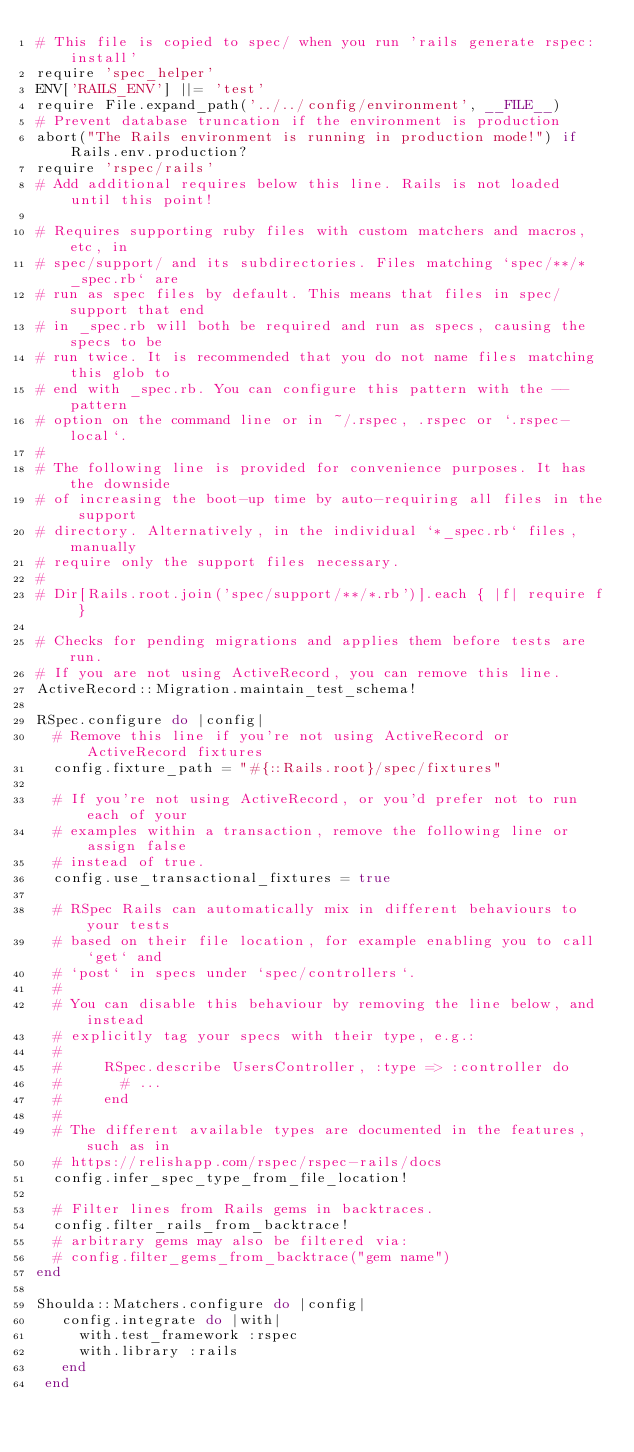<code> <loc_0><loc_0><loc_500><loc_500><_Ruby_># This file is copied to spec/ when you run 'rails generate rspec:install'
require 'spec_helper'
ENV['RAILS_ENV'] ||= 'test'
require File.expand_path('../../config/environment', __FILE__)
# Prevent database truncation if the environment is production
abort("The Rails environment is running in production mode!") if Rails.env.production?
require 'rspec/rails'
# Add additional requires below this line. Rails is not loaded until this point!

# Requires supporting ruby files with custom matchers and macros, etc, in
# spec/support/ and its subdirectories. Files matching `spec/**/*_spec.rb` are
# run as spec files by default. This means that files in spec/support that end
# in _spec.rb will both be required and run as specs, causing the specs to be
# run twice. It is recommended that you do not name files matching this glob to
# end with _spec.rb. You can configure this pattern with the --pattern
# option on the command line or in ~/.rspec, .rspec or `.rspec-local`.
#
# The following line is provided for convenience purposes. It has the downside
# of increasing the boot-up time by auto-requiring all files in the support
# directory. Alternatively, in the individual `*_spec.rb` files, manually
# require only the support files necessary.
#
# Dir[Rails.root.join('spec/support/**/*.rb')].each { |f| require f }

# Checks for pending migrations and applies them before tests are run.
# If you are not using ActiveRecord, you can remove this line.
ActiveRecord::Migration.maintain_test_schema!

RSpec.configure do |config|
  # Remove this line if you're not using ActiveRecord or ActiveRecord fixtures
  config.fixture_path = "#{::Rails.root}/spec/fixtures"

  # If you're not using ActiveRecord, or you'd prefer not to run each of your
  # examples within a transaction, remove the following line or assign false
  # instead of true.
  config.use_transactional_fixtures = true

  # RSpec Rails can automatically mix in different behaviours to your tests
  # based on their file location, for example enabling you to call `get` and
  # `post` in specs under `spec/controllers`.
  #
  # You can disable this behaviour by removing the line below, and instead
  # explicitly tag your specs with their type, e.g.:
  #
  #     RSpec.describe UsersController, :type => :controller do
  #       # ...
  #     end
  #
  # The different available types are documented in the features, such as in
  # https://relishapp.com/rspec/rspec-rails/docs
  config.infer_spec_type_from_file_location!

  # Filter lines from Rails gems in backtraces.
  config.filter_rails_from_backtrace!
  # arbitrary gems may also be filtered via:
  # config.filter_gems_from_backtrace("gem name")
end

Shoulda::Matchers.configure do |config|
   config.integrate do |with|
     with.test_framework :rspec
     with.library :rails
   end
 end
</code> 